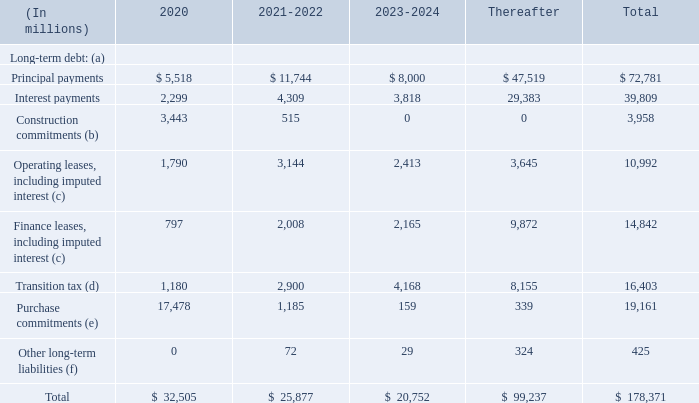Contractual Obligations
The following table summarizes the payments due by fiscal year for our outstanding contractual obligations as of June 30, 2019:
(a) Refer to Note 11 – Debt of the Notes to Financial Statements.
(b) Refer to Note 7 – Property and Equipment of the Notes to Financial Statements.
(c) Refer to Note 15 – Leases of the Notes to Financial Statements.
(d) Refer to Note 12 – Income Taxes of the Notes to Financial Statements.
(e) Amounts represent purchase commitments, including open purchase orders and take-or-pay contracts that are not presented as construction commitments above.
(f) We have excluded long-term tax contingencies, other tax liabilities, and deferred income taxes of $14.2 billion from the amounts presented as the timing of these obligations is uncertain. We have also excluded unearned revenue and non-cash items.
Why has $14.2 billion been excluded from other long-term liabilities? We have excluded long-term tax contingencies, other tax liabilities, and deferred income taxes of $14.2 billion from the amounts presented as the timing of these obligations is uncertain. What do the purchase commitments represent? Amounts represent purchase commitments, including open purchase orders and take-or-pay contracts that are not presented as construction commitments above. Where can the long-term debt be found? Refer to note 11 – debt of the notes to financial statements. How much do the top 3 contractual obligation terms add up to in 2020?
Answer scale should be: million. 5,518 + 17,478+3,443
Answer: 26439. What are the construction commitments in 2020 as a percentage of the total contractual obligations?
Answer scale should be: percent. 3,443/32,505
Answer: 10.59. What is the percentage change in interest payments from 2020 to 2021-2022?
Answer scale should be: percent. (4,309-2,299)/2,299
Answer: 87.43. 